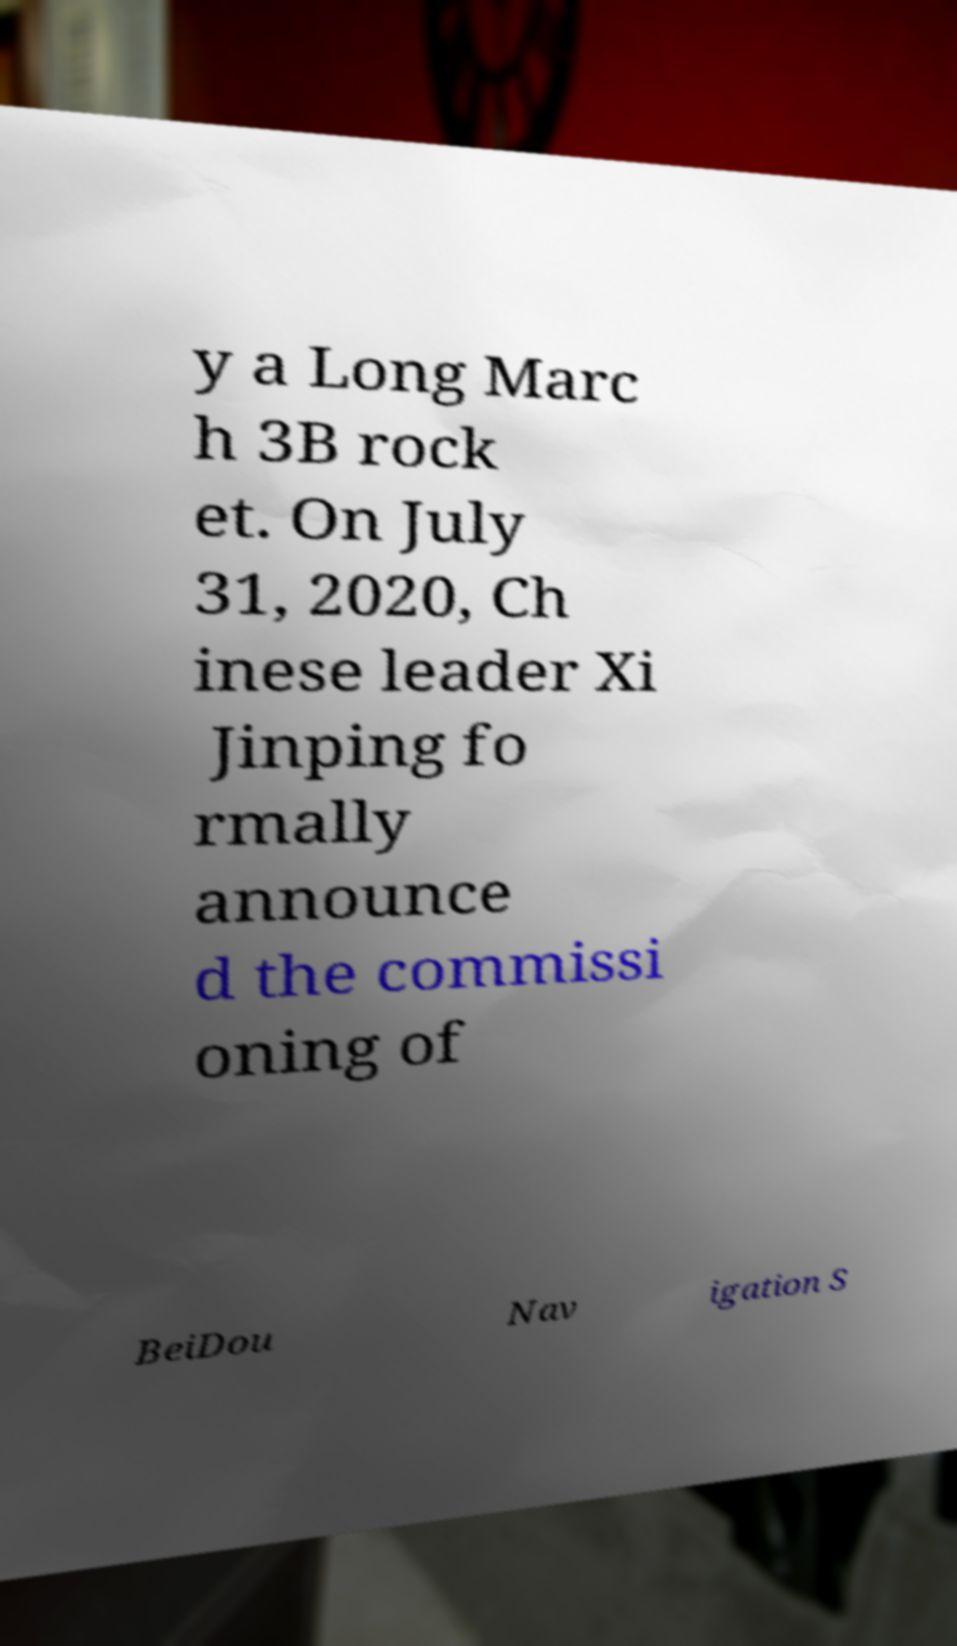Please identify and transcribe the text found in this image. y a Long Marc h 3B rock et. On July 31, 2020, Ch inese leader Xi Jinping fo rmally announce d the commissi oning of BeiDou Nav igation S 